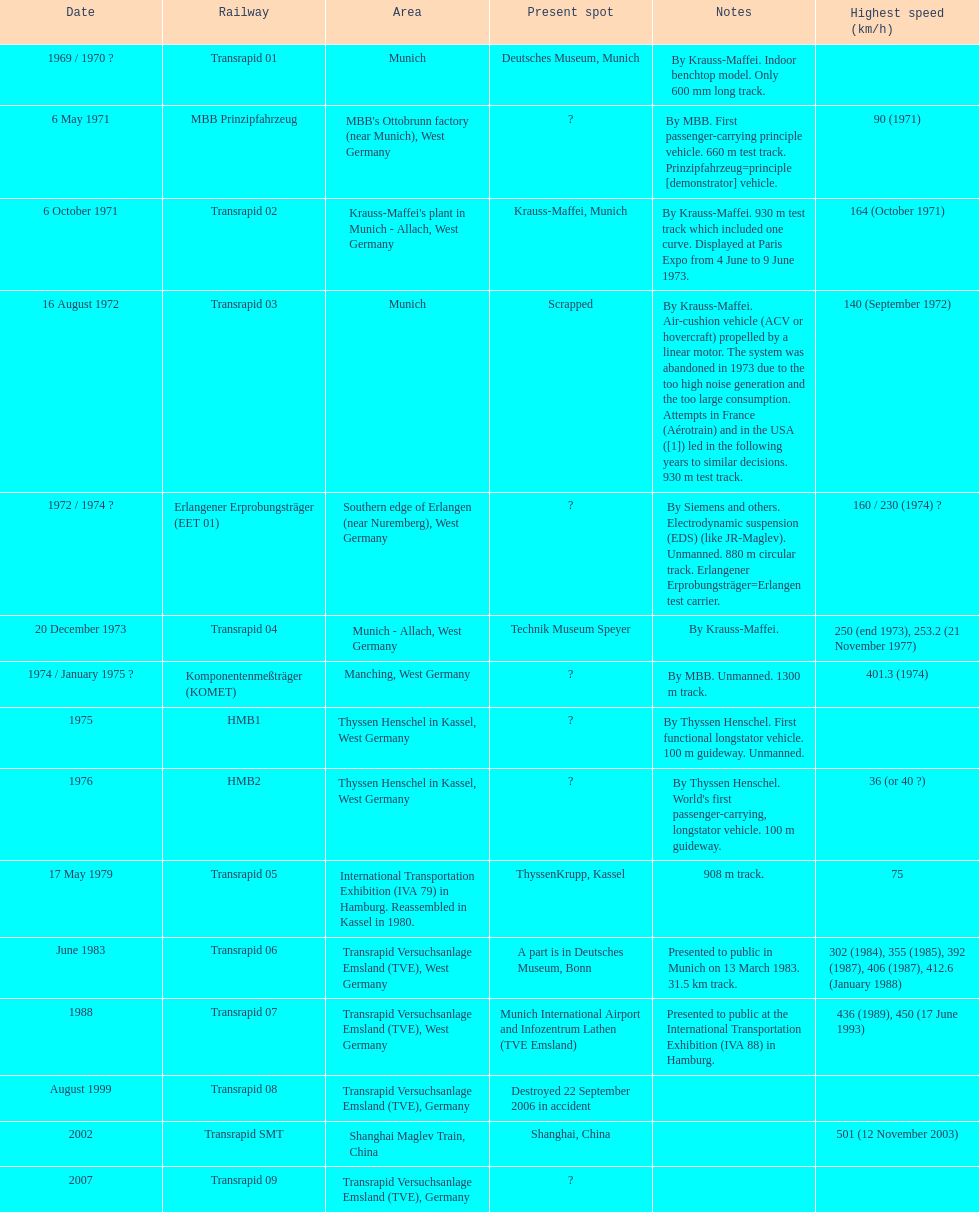High noise generation and too large consumption led to what train being scrapped? Transrapid 03. 